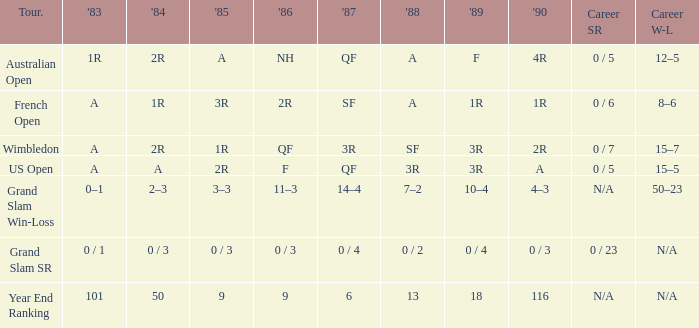In 1983, which competition has a 0/1 score? Grand Slam SR. 